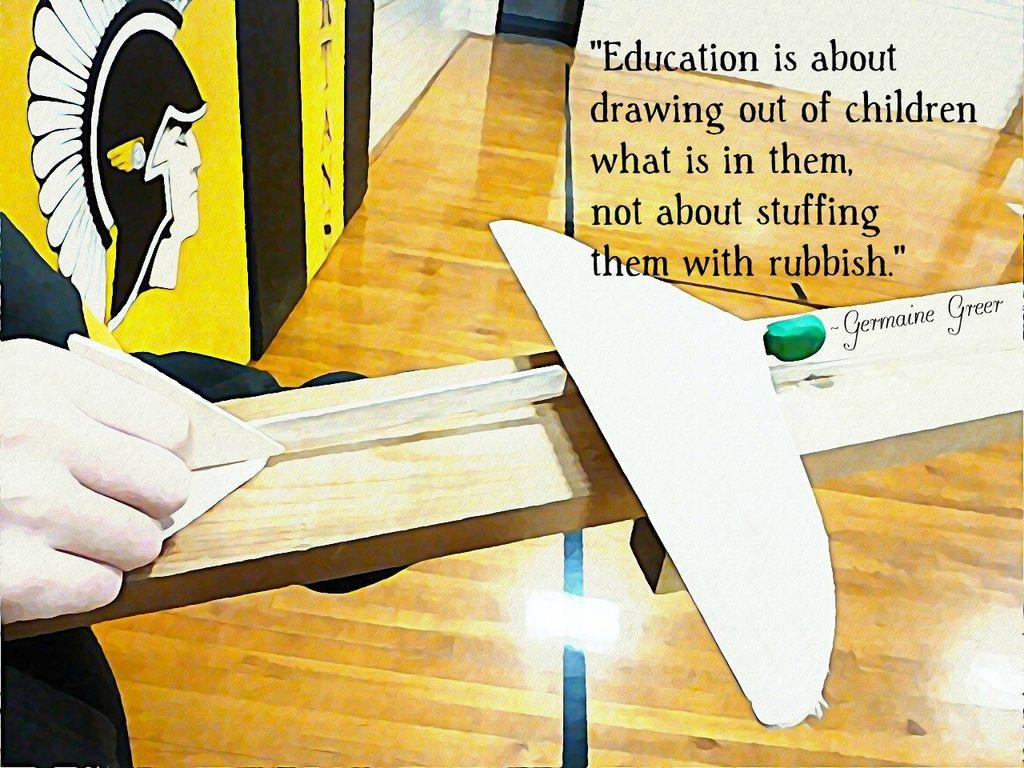Provide a one-sentence caption for the provided image. A person is holding a Germaine Greer model in their hand. 